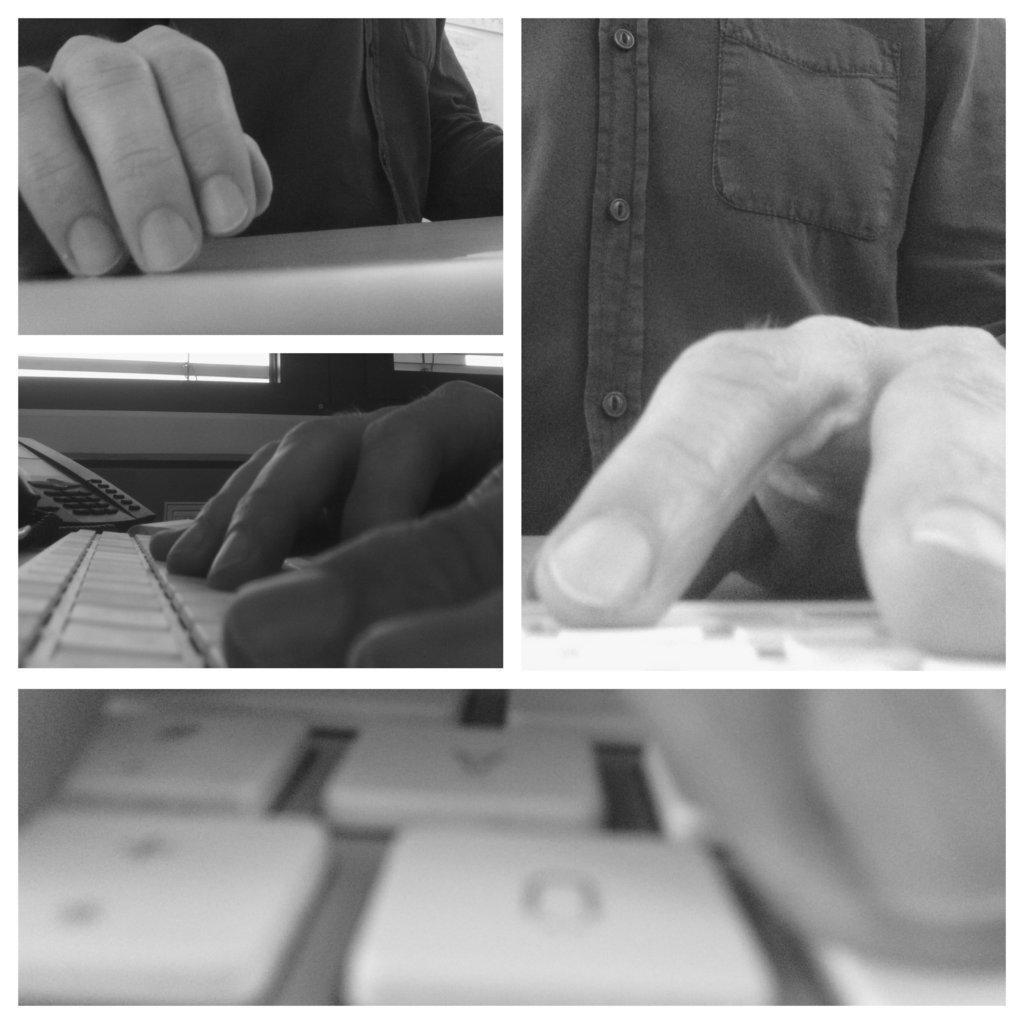What type of image is being described? The image is a collage. Can you identify any subjects or objects in the collage? Yes, there is a person in the image. What is the person doing in the image? The person is using a keyboard. How many fingers are visible on the person's hand while using the volleyball in the image? There is no volleyball present in the image, and therefore no fingers can be counted in relation to it. 